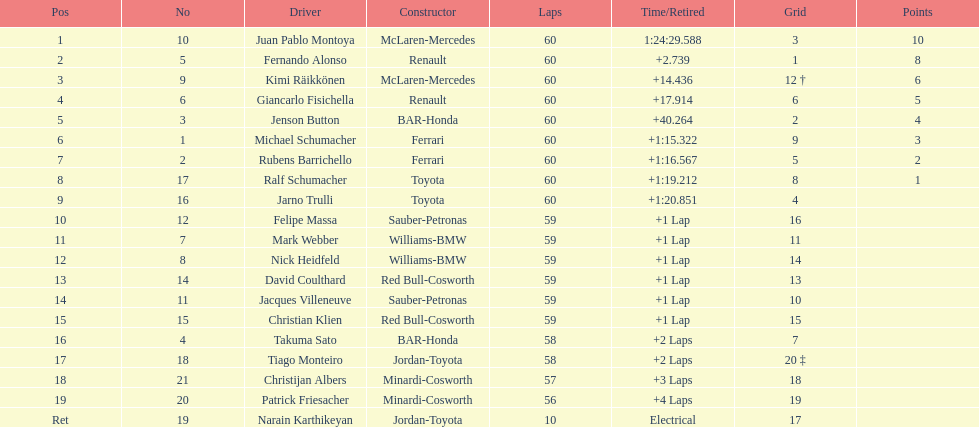Whose grid is set at number 2 among the drivers? Jenson Button. 